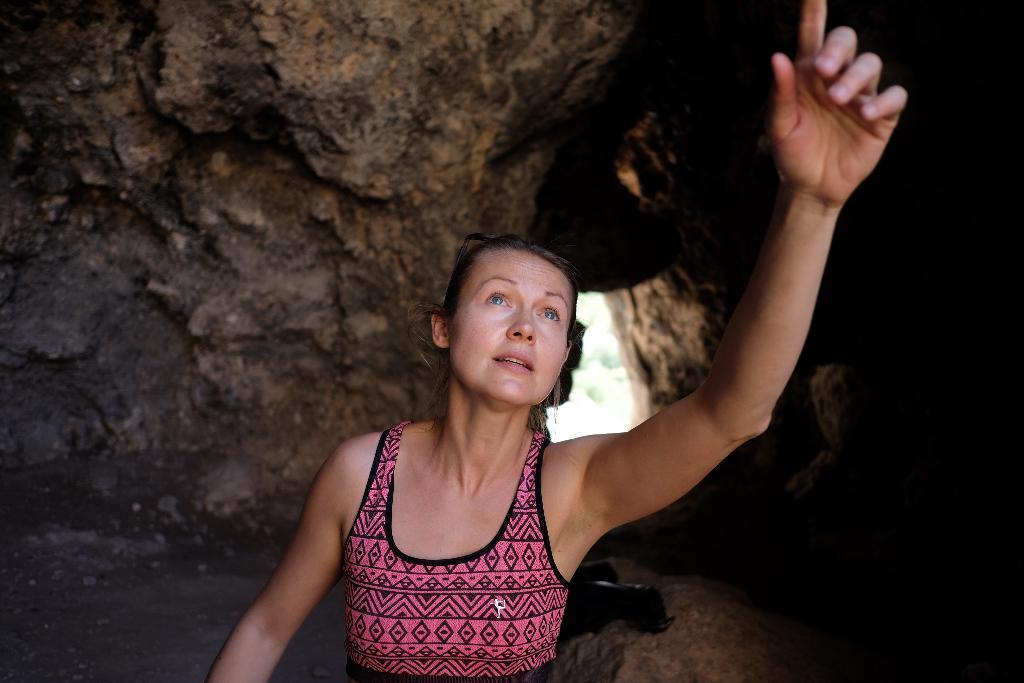Please provide a concise description of this image. In this image in the foreground ,we can see a woman looking at someone and at the back it looks like a cave. 